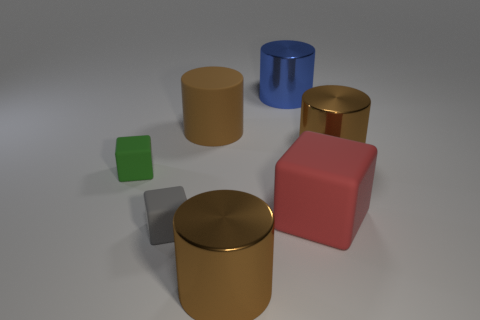How many blue things are the same material as the red thing?
Your answer should be very brief. 0. Is the material of the cylinder in front of the big cube the same as the block right of the blue cylinder?
Provide a short and direct response. No. How many large brown cylinders are behind the big brown cylinder that is in front of the matte cube that is to the right of the matte cylinder?
Offer a very short reply. 2. There is a tiny object to the left of the small gray object; does it have the same color as the metal cylinder in front of the small gray matte thing?
Provide a short and direct response. No. Is there any other thing of the same color as the large block?
Offer a very short reply. No. There is a cylinder in front of the big brown shiny cylinder on the right side of the blue metallic cylinder; what is its color?
Your answer should be compact. Brown. Is there a red thing?
Offer a very short reply. Yes. There is a matte cube that is in front of the small green matte block and to the left of the large blue shiny object; what color is it?
Your response must be concise. Gray. Is the size of the brown metal cylinder to the left of the large blue thing the same as the gray matte thing that is to the right of the tiny green thing?
Provide a succinct answer. No. What number of other objects are there of the same size as the red rubber object?
Your answer should be compact. 4. 